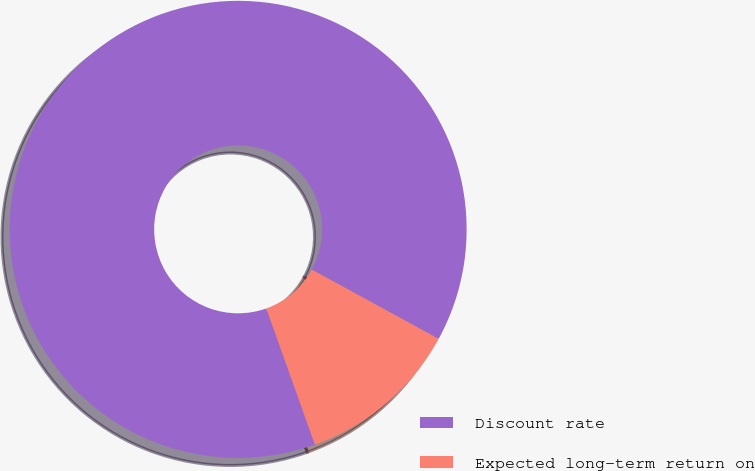<chart> <loc_0><loc_0><loc_500><loc_500><pie_chart><fcel>Discount rate<fcel>Expected long-term return on<nl><fcel>88.41%<fcel>11.59%<nl></chart> 